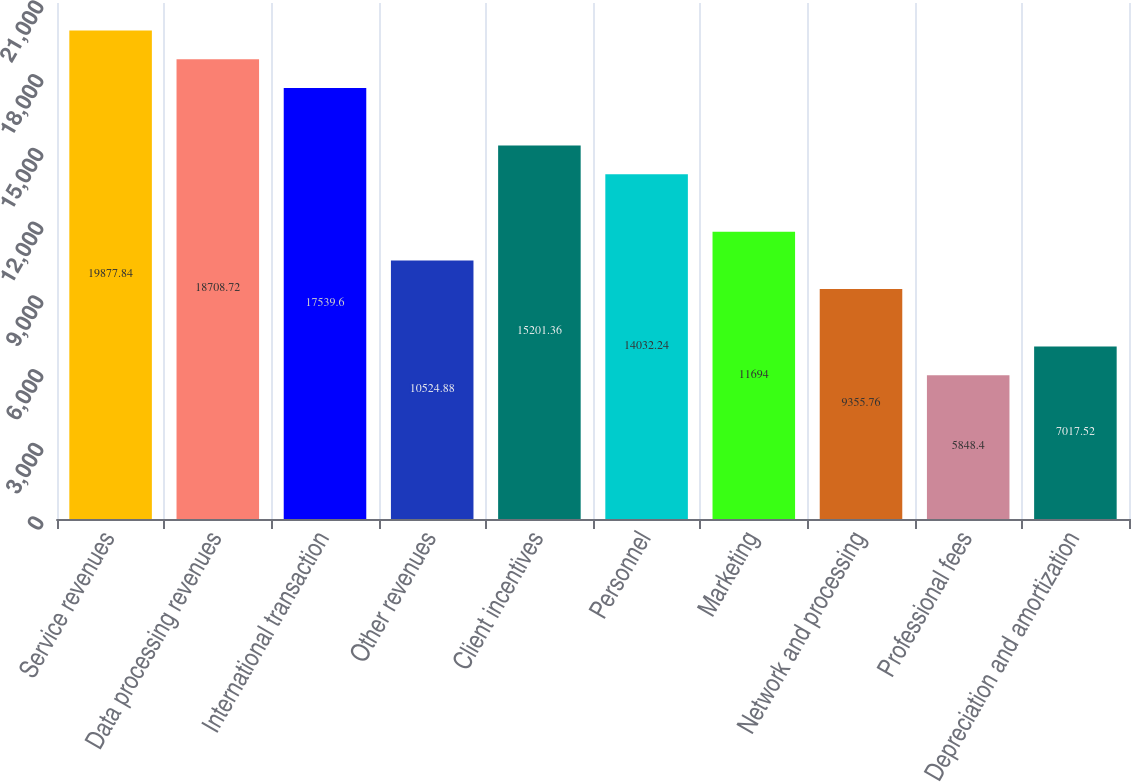<chart> <loc_0><loc_0><loc_500><loc_500><bar_chart><fcel>Service revenues<fcel>Data processing revenues<fcel>International transaction<fcel>Other revenues<fcel>Client incentives<fcel>Personnel<fcel>Marketing<fcel>Network and processing<fcel>Professional fees<fcel>Depreciation and amortization<nl><fcel>19877.8<fcel>18708.7<fcel>17539.6<fcel>10524.9<fcel>15201.4<fcel>14032.2<fcel>11694<fcel>9355.76<fcel>5848.4<fcel>7017.52<nl></chart> 